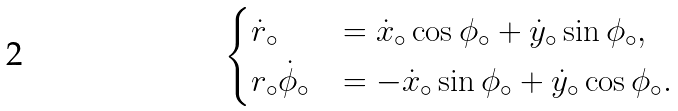<formula> <loc_0><loc_0><loc_500><loc_500>\begin{cases} \dot { r } _ { \circ } & = \dot { x } _ { \circ } \cos { \phi _ { \circ } } + \dot { y } _ { \circ } \sin { \phi _ { \circ } } , \\ r _ { \circ } \dot { \phi } _ { \circ } & = - \dot { x } _ { \circ } \sin { \phi _ { \circ } } + \dot { y } _ { \circ } \cos { \phi _ { \circ } } . \\ \end{cases}</formula> 